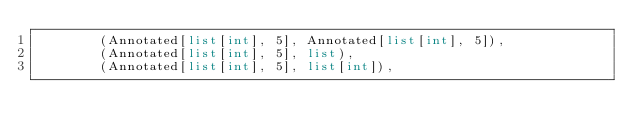<code> <loc_0><loc_0><loc_500><loc_500><_Python_>        (Annotated[list[int], 5], Annotated[list[int], 5]),
        (Annotated[list[int], 5], list),
        (Annotated[list[int], 5], list[int]),</code> 